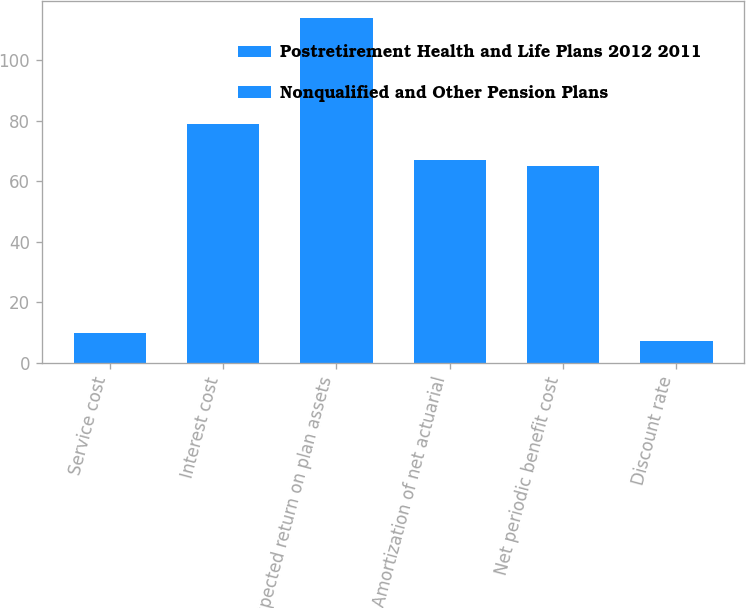Convert chart to OTSL. <chart><loc_0><loc_0><loc_500><loc_500><stacked_bar_chart><ecel><fcel>Service cost<fcel>Interest cost<fcel>Expected return on plan assets<fcel>Amortization of net actuarial<fcel>Net periodic benefit cost<fcel>Discount rate<nl><fcel>Postretirement Health and Life Plans 2012 2011<fcel>1<fcel>25<fcel>109<fcel>25<fcel>39<fcel>3.65<nl><fcel>Nonqualified and Other Pension Plans<fcel>9<fcel>54<fcel>5<fcel>42<fcel>26<fcel>3.65<nl></chart> 